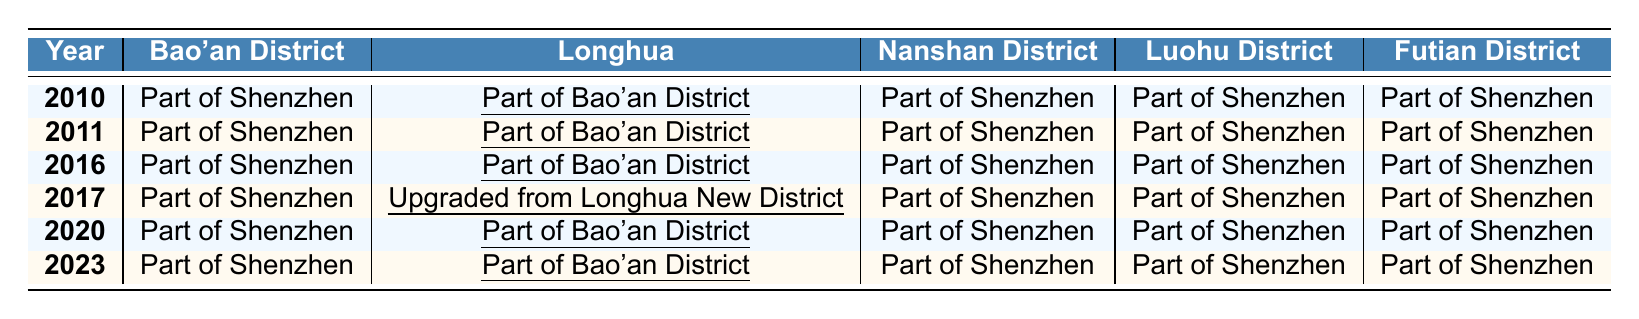What was the status of Longhua in 2010? In 2010, Longhua was listed as "Part of Bao'an District" according to the table.
Answer: Part of Bao'an District How many times did Longhua change its status from 2010 to 2023? Longhua's status changed three times: it was "Part of Bao'an District" in 2010, upgraded in 2017, and became an "Independent District" in 2020, maintaining that status in 2023.
Answer: Three times Is Longhua still part of Bao'an District in 2023? In 2023, Longhua is listed as an "Independent District," meaning it is no longer part of Bao'an District.
Answer: No What year did Longhua upgrade from Longhua New District? Longhua upgraded from Longhua New District in the year 2017, as indicated in the table.
Answer: 2017 From 2010 to 2016, what was the status of Longhua? From 2010 to 2016, Longhua's status consistently remained "Part of Bao'an District," as shown in the table for those years.
Answer: Part of Bao'an District In which year did Longhua become an Independent District? Longhua became an Independent District in 2020, based on the table.
Answer: 2020 What is the difference in the classification of Longhua between 2016 and 2020? In 2016, Longhua was "Part of Bao'an District," and by 2020 it was classified as an "Independent District," indicating a change in governance status.
Answer: Became Independent District How many districts are still listed as "Part of Shenzhen" in 2023? In 2023, there are four districts listed as "Part of Shenzhen": Bao'an District, Nanshan District, Luohu District, and Futian District.
Answer: Four districts If we compare the years 2010 and 2023, what has changed regarding Longhua's status? In 2010, Longhua was "Part of Bao'an District," while in 2023 it is an "Independent District." This shows a significant administrative change over this period.
Answer: Longhua became Independent What was the administrative status of Longhua between 2011 and 2016? Longhua maintained the status of being "Part of Bao'an District" during the years of 2011, 2016, indicating no changes occurred in that timeframe.
Answer: Part of Bao'an District 